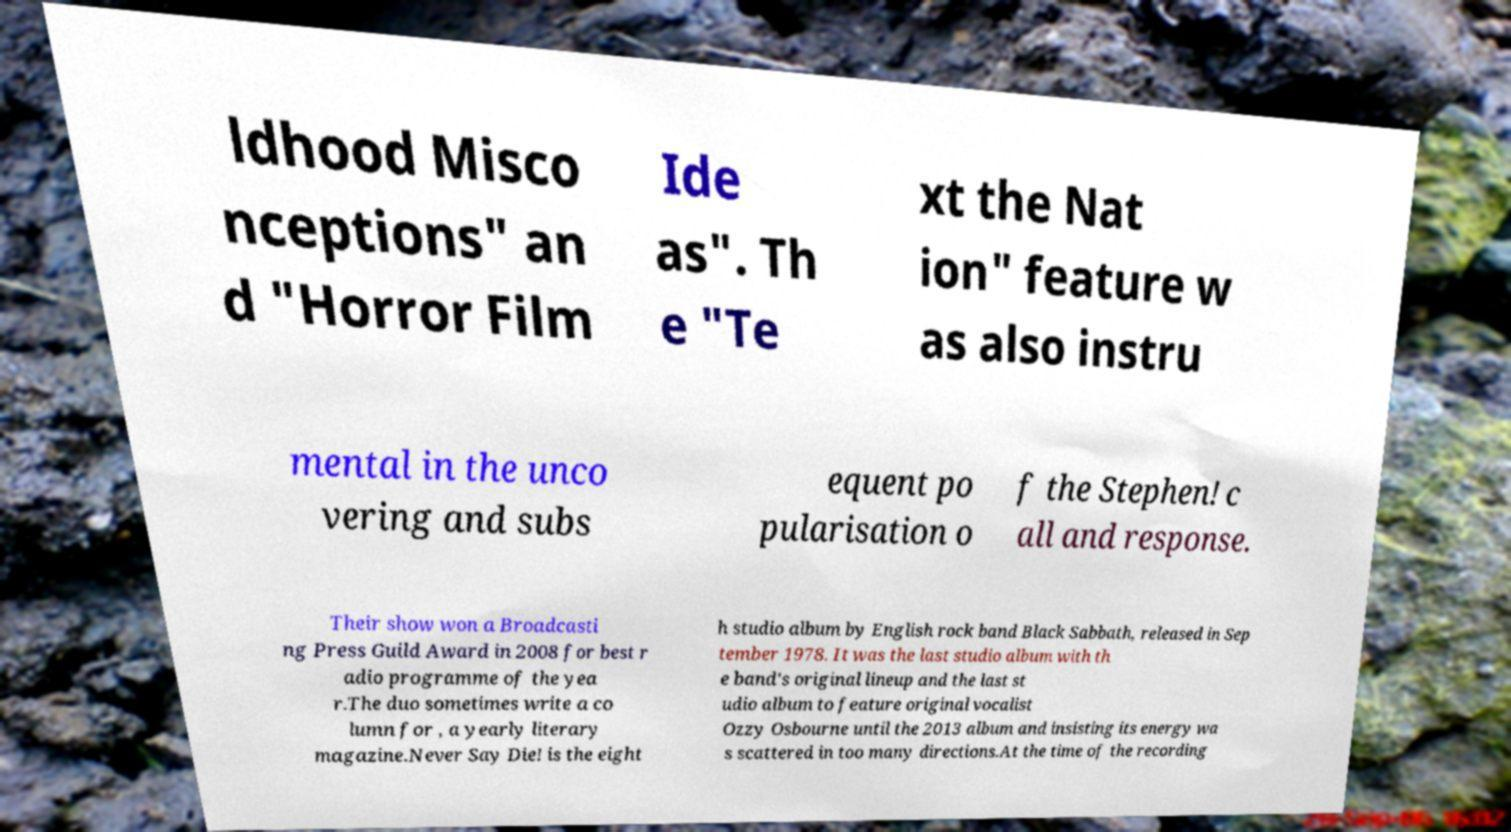There's text embedded in this image that I need extracted. Can you transcribe it verbatim? ldhood Misco nceptions" an d "Horror Film Ide as". Th e "Te xt the Nat ion" feature w as also instru mental in the unco vering and subs equent po pularisation o f the Stephen! c all and response. Their show won a Broadcasti ng Press Guild Award in 2008 for best r adio programme of the yea r.The duo sometimes write a co lumn for , a yearly literary magazine.Never Say Die! is the eight h studio album by English rock band Black Sabbath, released in Sep tember 1978. It was the last studio album with th e band's original lineup and the last st udio album to feature original vocalist Ozzy Osbourne until the 2013 album and insisting its energy wa s scattered in too many directions.At the time of the recording 